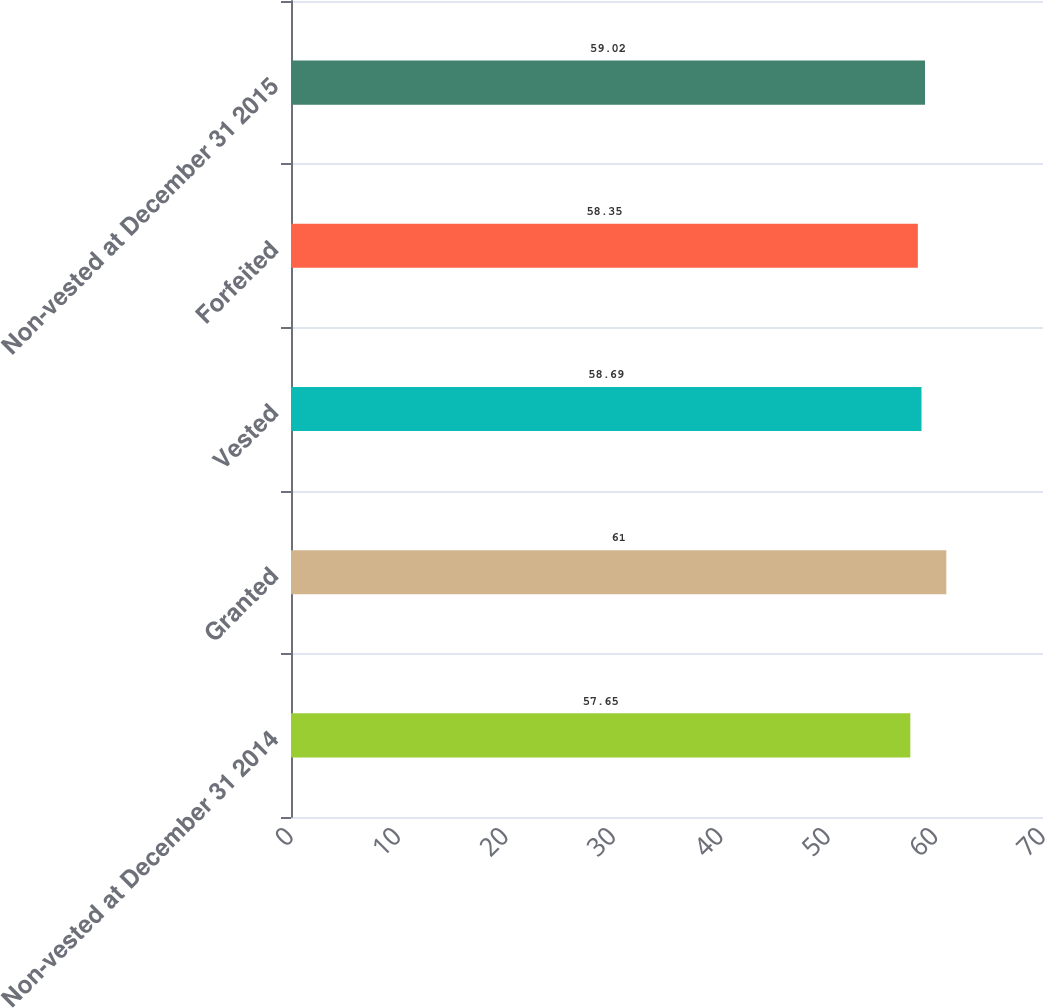Convert chart to OTSL. <chart><loc_0><loc_0><loc_500><loc_500><bar_chart><fcel>Non-vested at December 31 2014<fcel>Granted<fcel>Vested<fcel>Forfeited<fcel>Non-vested at December 31 2015<nl><fcel>57.65<fcel>61<fcel>58.69<fcel>58.35<fcel>59.02<nl></chart> 